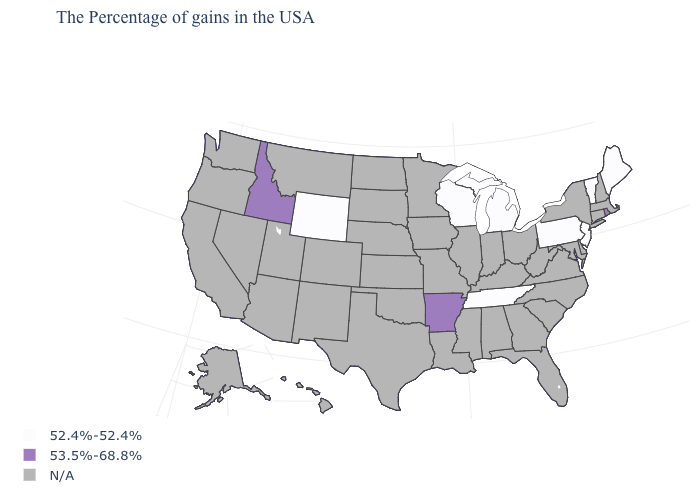What is the highest value in the USA?
Concise answer only. 53.5%-68.8%. What is the value of Nevada?
Quick response, please. N/A. Name the states that have a value in the range 52.4%-52.4%?
Quick response, please. Maine, Vermont, New Jersey, Pennsylvania, Michigan, Tennessee, Wisconsin, Wyoming. Name the states that have a value in the range 52.4%-52.4%?
Give a very brief answer. Maine, Vermont, New Jersey, Pennsylvania, Michigan, Tennessee, Wisconsin, Wyoming. Among the states that border Delaware , which have the lowest value?
Write a very short answer. New Jersey, Pennsylvania. Does New Jersey have the lowest value in the USA?
Be succinct. Yes. What is the value of New Hampshire?
Give a very brief answer. N/A. How many symbols are there in the legend?
Short answer required. 3. Does Tennessee have the lowest value in the South?
Short answer required. Yes. What is the highest value in the USA?
Write a very short answer. 53.5%-68.8%. What is the value of Missouri?
Give a very brief answer. N/A. Does Arkansas have the lowest value in the USA?
Concise answer only. No. 